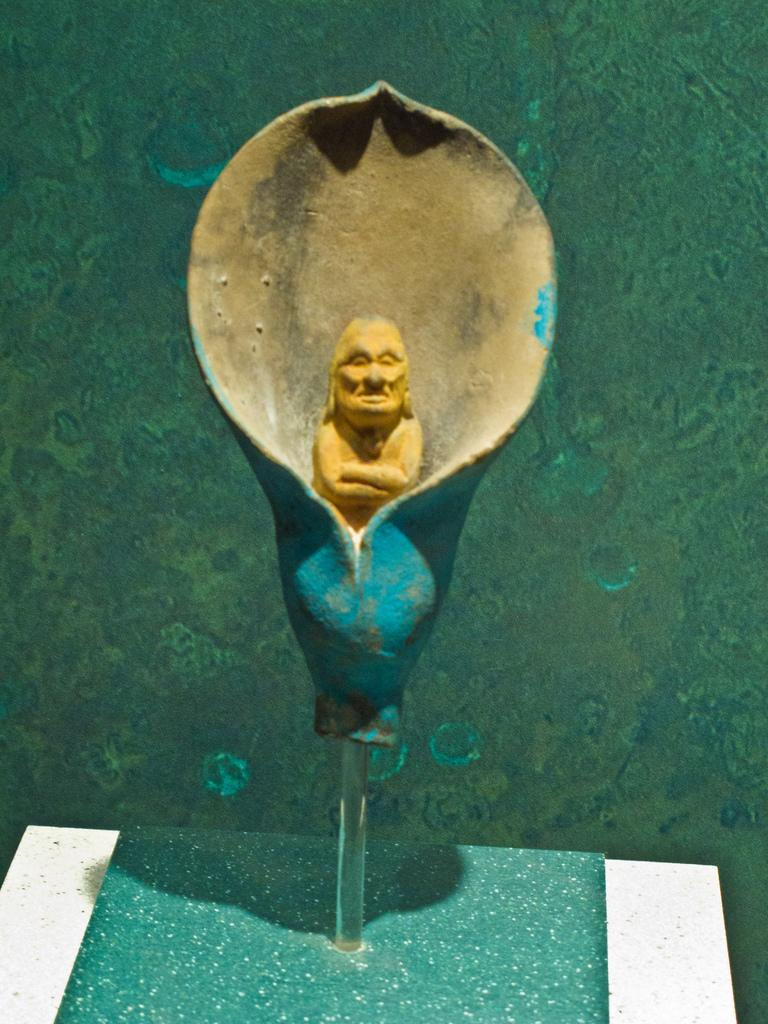What is the main subject in the middle of the image? There is a statue in the middle of the image. What can be seen in the background of the image? There is a wall in the background of the image. What type of vase is placed on the statue in the image? There is no vase present on the statue in the image. What type of whip can be seen being used by the statue in the image? There is no whip present in the image, and the statue is not using any object. What type of knife is being held by the statue in the image? There is no knife present in the image, and the statue is not holding any object. 